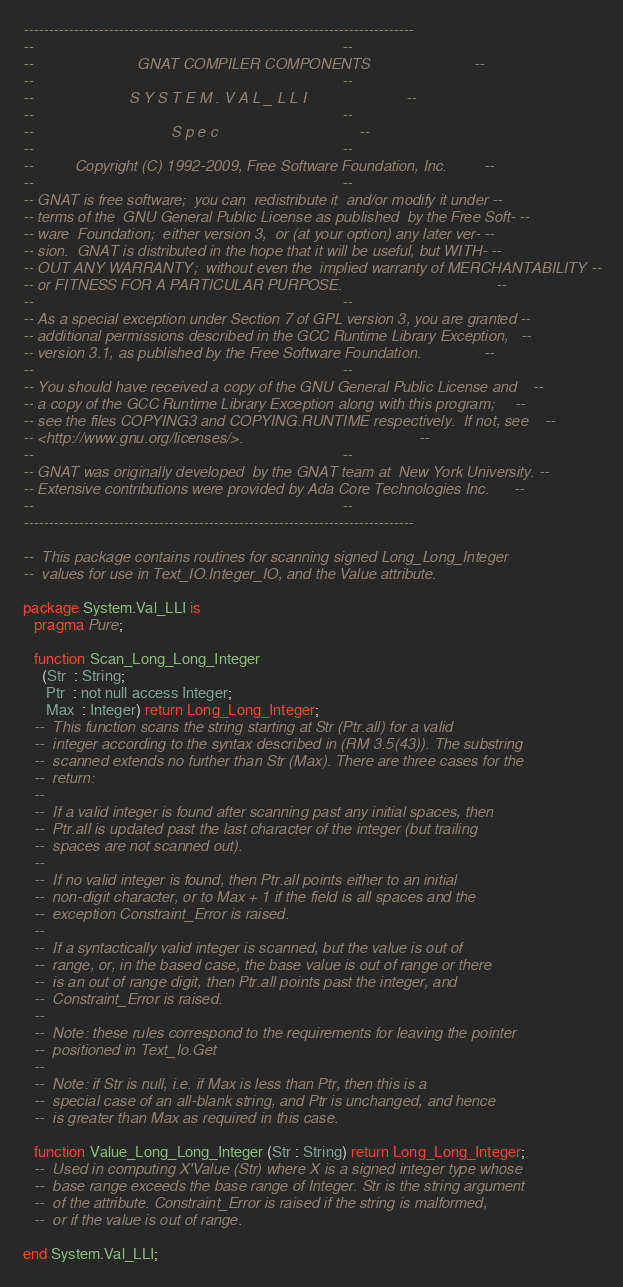<code> <loc_0><loc_0><loc_500><loc_500><_Ada_>------------------------------------------------------------------------------
--                                                                          --
--                         GNAT COMPILER COMPONENTS                         --
--                                                                          --
--                       S Y S T E M . V A L _ L L I                        --
--                                                                          --
--                                 S p e c                                  --
--                                                                          --
--          Copyright (C) 1992-2009, Free Software Foundation, Inc.         --
--                                                                          --
-- GNAT is free software;  you can  redistribute it  and/or modify it under --
-- terms of the  GNU General Public License as published  by the Free Soft- --
-- ware  Foundation;  either version 3,  or (at your option) any later ver- --
-- sion.  GNAT is distributed in the hope that it will be useful, but WITH- --
-- OUT ANY WARRANTY;  without even the  implied warranty of MERCHANTABILITY --
-- or FITNESS FOR A PARTICULAR PURPOSE.                                     --
--                                                                          --
-- As a special exception under Section 7 of GPL version 3, you are granted --
-- additional permissions described in the GCC Runtime Library Exception,   --
-- version 3.1, as published by the Free Software Foundation.               --
--                                                                          --
-- You should have received a copy of the GNU General Public License and    --
-- a copy of the GCC Runtime Library Exception along with this program;     --
-- see the files COPYING3 and COPYING.RUNTIME respectively.  If not, see    --
-- <http://www.gnu.org/licenses/>.                                          --
--                                                                          --
-- GNAT was originally developed  by the GNAT team at  New York University. --
-- Extensive contributions were provided by Ada Core Technologies Inc.      --
--                                                                          --
------------------------------------------------------------------------------

--  This package contains routines for scanning signed Long_Long_Integer
--  values for use in Text_IO.Integer_IO, and the Value attribute.

package System.Val_LLI is
   pragma Pure;

   function Scan_Long_Long_Integer
     (Str  : String;
      Ptr  : not null access Integer;
      Max  : Integer) return Long_Long_Integer;
   --  This function scans the string starting at Str (Ptr.all) for a valid
   --  integer according to the syntax described in (RM 3.5(43)). The substring
   --  scanned extends no further than Str (Max). There are three cases for the
   --  return:
   --
   --  If a valid integer is found after scanning past any initial spaces, then
   --  Ptr.all is updated past the last character of the integer (but trailing
   --  spaces are not scanned out).
   --
   --  If no valid integer is found, then Ptr.all points either to an initial
   --  non-digit character, or to Max + 1 if the field is all spaces and the
   --  exception Constraint_Error is raised.
   --
   --  If a syntactically valid integer is scanned, but the value is out of
   --  range, or, in the based case, the base value is out of range or there
   --  is an out of range digit, then Ptr.all points past the integer, and
   --  Constraint_Error is raised.
   --
   --  Note: these rules correspond to the requirements for leaving the pointer
   --  positioned in Text_Io.Get
   --
   --  Note: if Str is null, i.e. if Max is less than Ptr, then this is a
   --  special case of an all-blank string, and Ptr is unchanged, and hence
   --  is greater than Max as required in this case.

   function Value_Long_Long_Integer (Str : String) return Long_Long_Integer;
   --  Used in computing X'Value (Str) where X is a signed integer type whose
   --  base range exceeds the base range of Integer. Str is the string argument
   --  of the attribute. Constraint_Error is raised if the string is malformed,
   --  or if the value is out of range.

end System.Val_LLI;
</code> 